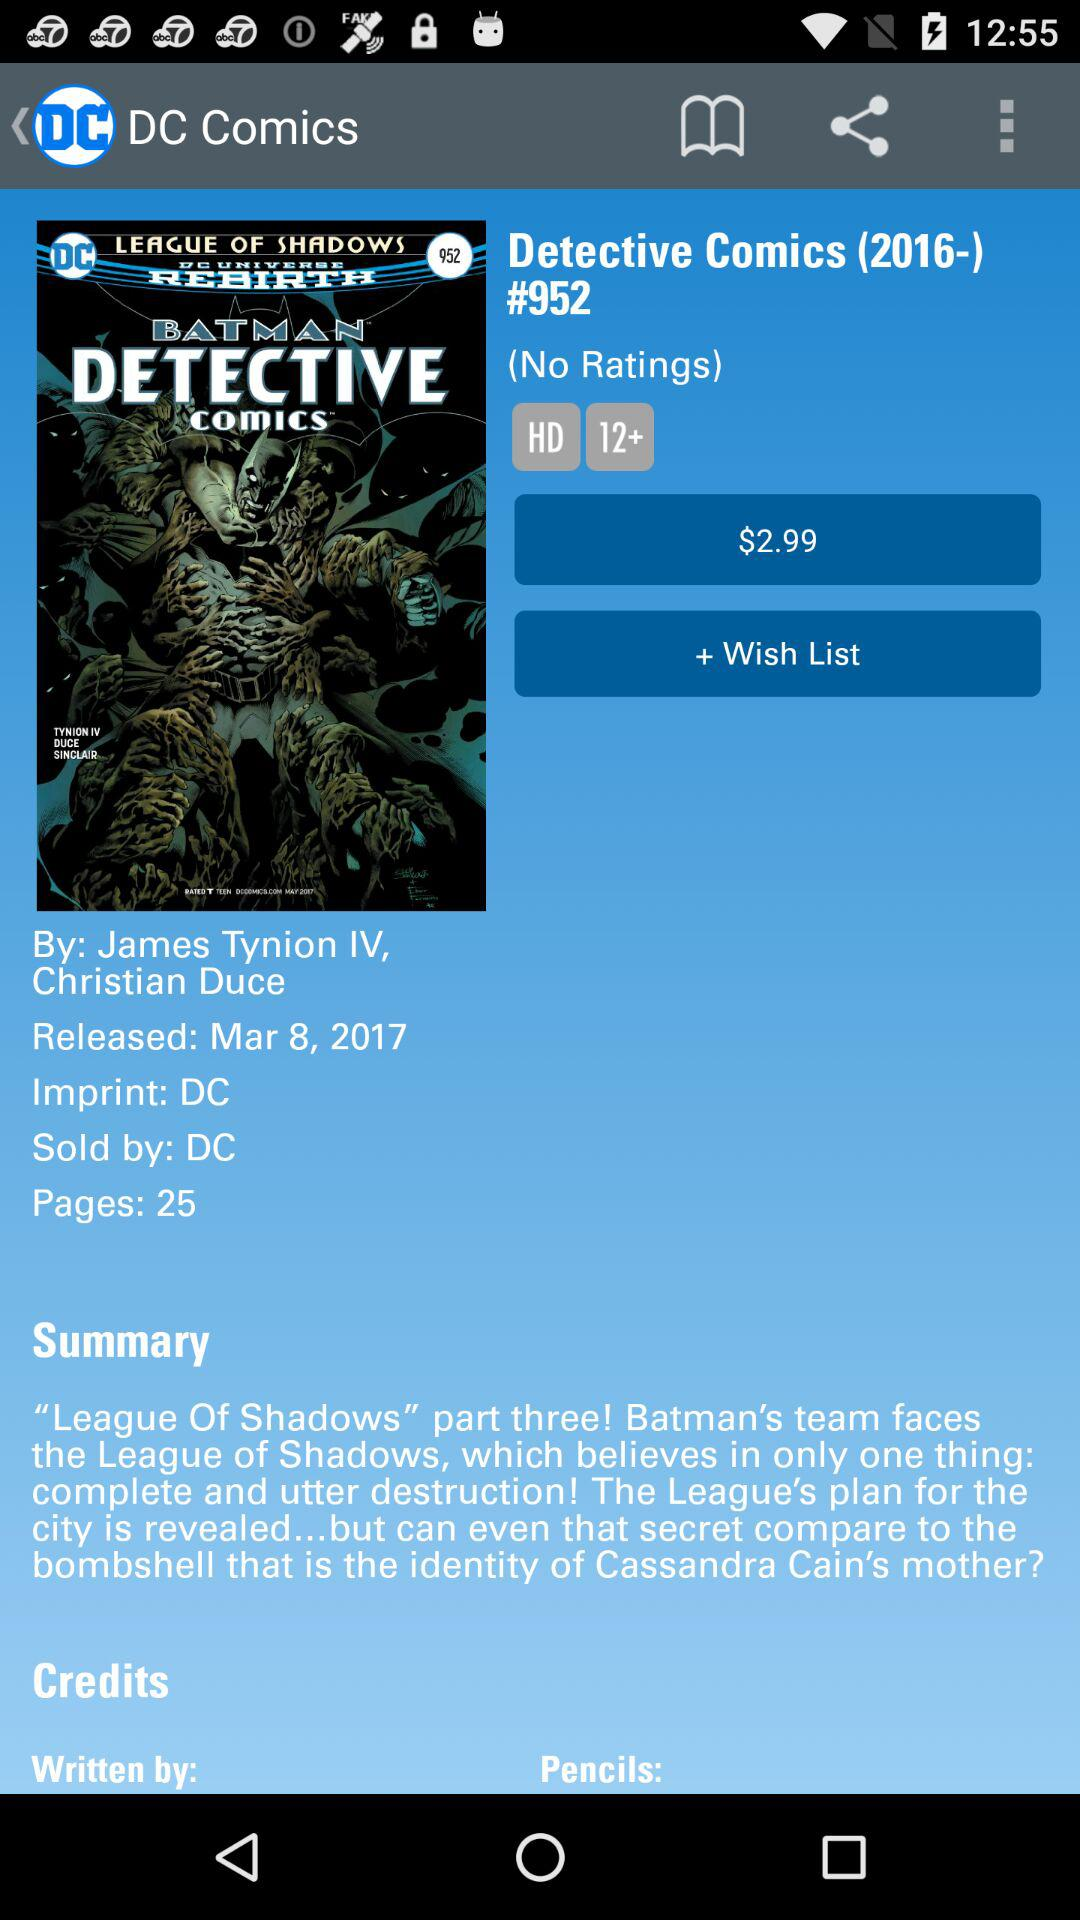What is the release date? The release date is March 8, 2017. 